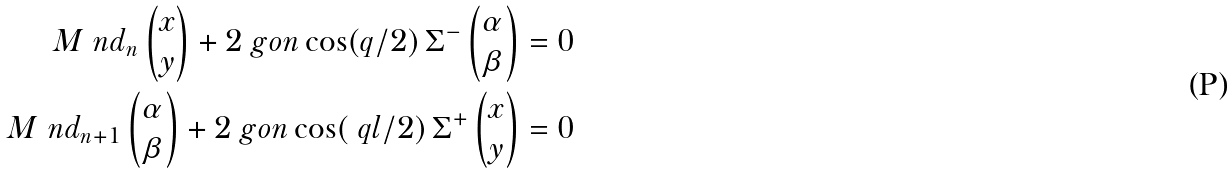Convert formula to latex. <formula><loc_0><loc_0><loc_500><loc_500>M \ n d _ { n } \begin{pmatrix} x \\ y \end{pmatrix} + 2 \ g o n \cos ( q / 2 ) \, \Sigma ^ { - } \begin{pmatrix} \alpha \\ \beta \end{pmatrix} & = 0 \\ M \ n d _ { n + 1 } \begin{pmatrix} \alpha \\ \beta \end{pmatrix} + 2 \ g o n \cos ( \ q l / 2 ) \, \Sigma ^ { + } \begin{pmatrix} x \\ y \end{pmatrix} & = 0</formula> 